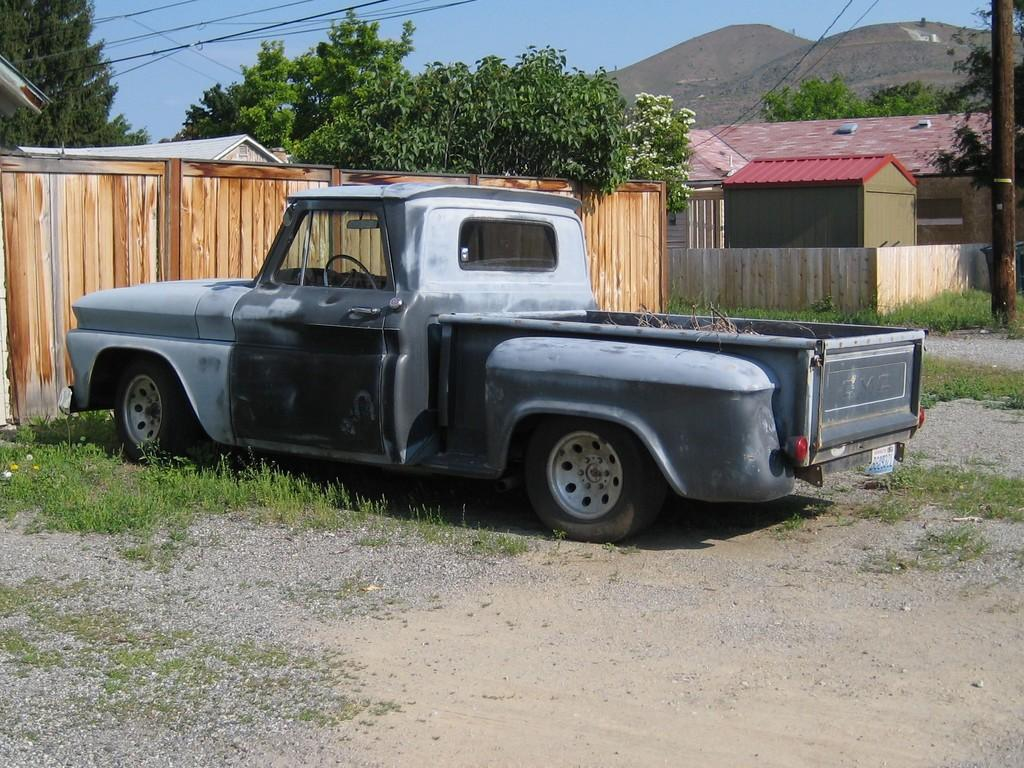What is the main subject of the image? There is a car in the image. What can be seen beside the car? There is grass beside the car. What is visible in the background of the image? Houses, cables, trees, and a pole are present in the background of the image. Can you hear the voice of the boys playing on the playground in the image? There is no playground or boys present in the image, so no such voice can be heard. 